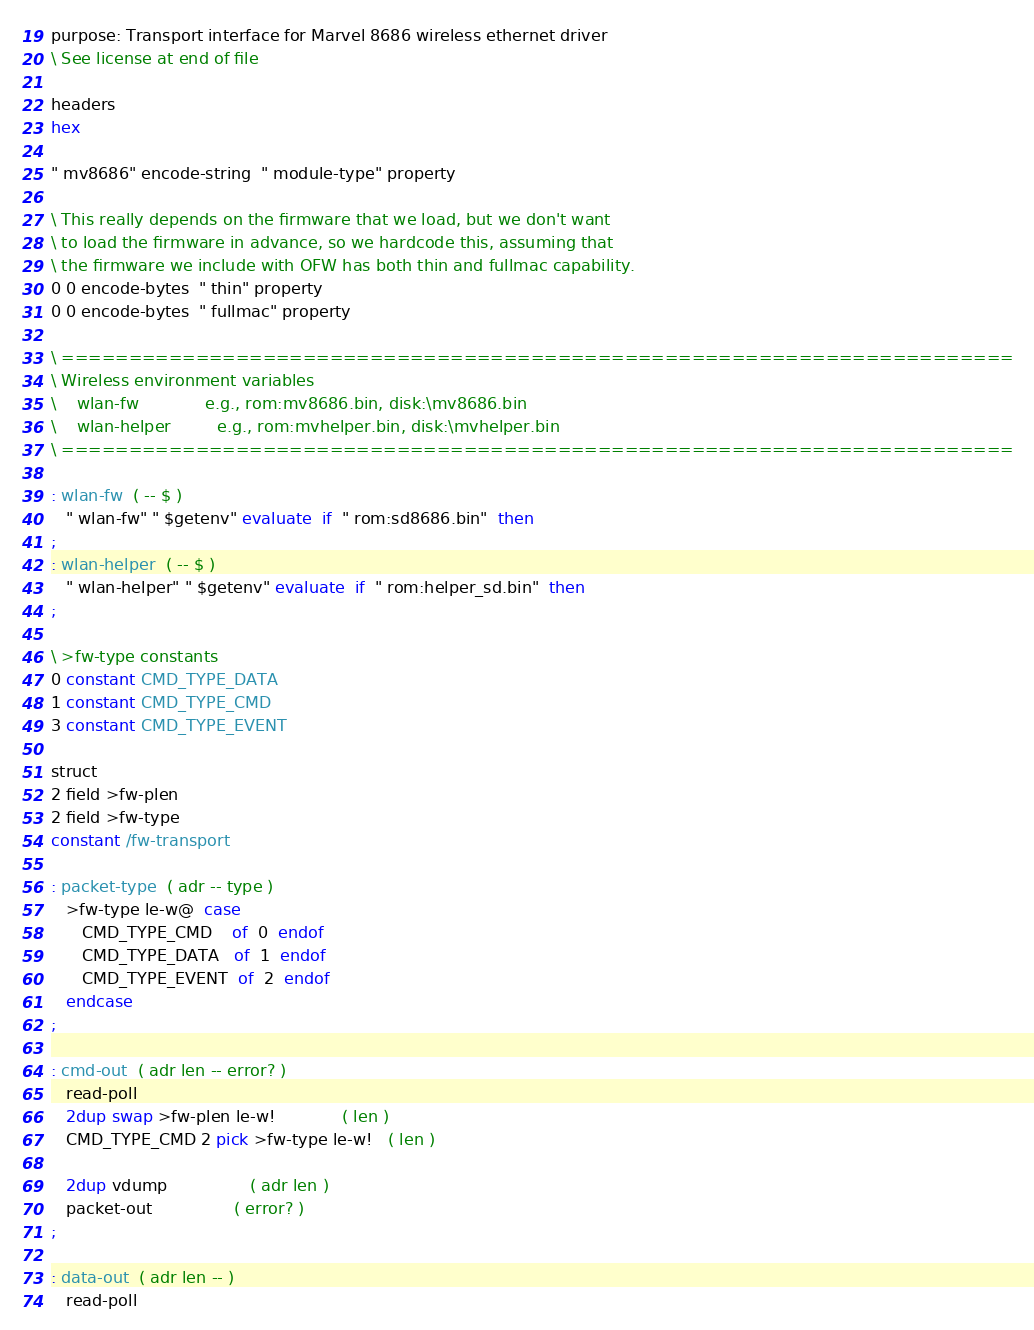<code> <loc_0><loc_0><loc_500><loc_500><_Forth_>purpose: Transport interface for Marvel 8686 wireless ethernet driver
\ See license at end of file

headers
hex

" mv8686" encode-string  " module-type" property

\ This really depends on the firmware that we load, but we don't want
\ to load the firmware in advance, so we hardcode this, assuming that
\ the firmware we include with OFW has both thin and fullmac capability.
0 0 encode-bytes  " thin" property
0 0 encode-bytes  " fullmac" property

\ =======================================================================
\ Wireless environment variables
\    wlan-fw             e.g., rom:mv8686.bin, disk:\mv8686.bin
\    wlan-helper         e.g., rom:mvhelper.bin, disk:\mvhelper.bin
\ =======================================================================

: wlan-fw  ( -- $ )
   " wlan-fw" " $getenv" evaluate  if  " rom:sd8686.bin"  then  
;
: wlan-helper  ( -- $ )
   " wlan-helper" " $getenv" evaluate  if  " rom:helper_sd.bin"  then
;

\ >fw-type constants
0 constant CMD_TYPE_DATA
1 constant CMD_TYPE_CMD
3 constant CMD_TYPE_EVENT

struct
2 field >fw-plen
2 field >fw-type
constant /fw-transport

: packet-type  ( adr -- type )
   >fw-type le-w@  case
      CMD_TYPE_CMD    of  0  endof
      CMD_TYPE_DATA   of  1  endof
      CMD_TYPE_EVENT  of  2  endof
   endcase
;

: cmd-out  ( adr len -- error? )
   read-poll
   2dup swap >fw-plen le-w!             ( len )
   CMD_TYPE_CMD 2 pick >fw-type le-w!   ( len )

   2dup vdump				( adr len )
   packet-out				( error? )
;

: data-out  ( adr len -- )
   read-poll</code> 